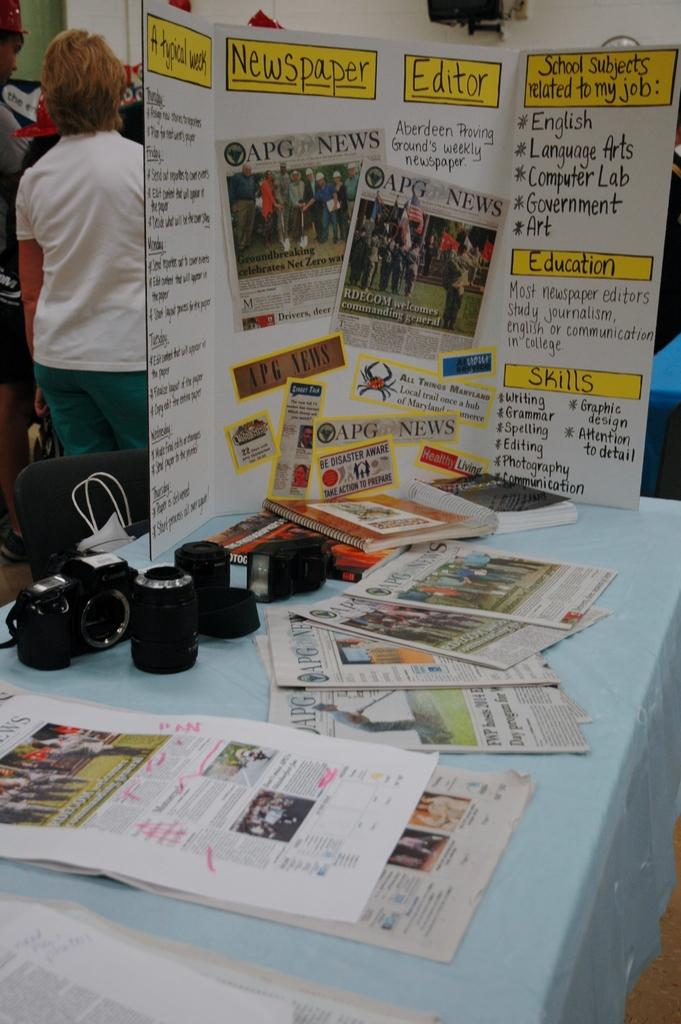<image>
Describe the image concisely. a table with a trifold featuring an experiment about newspapers and the different facets like shills and editors. 